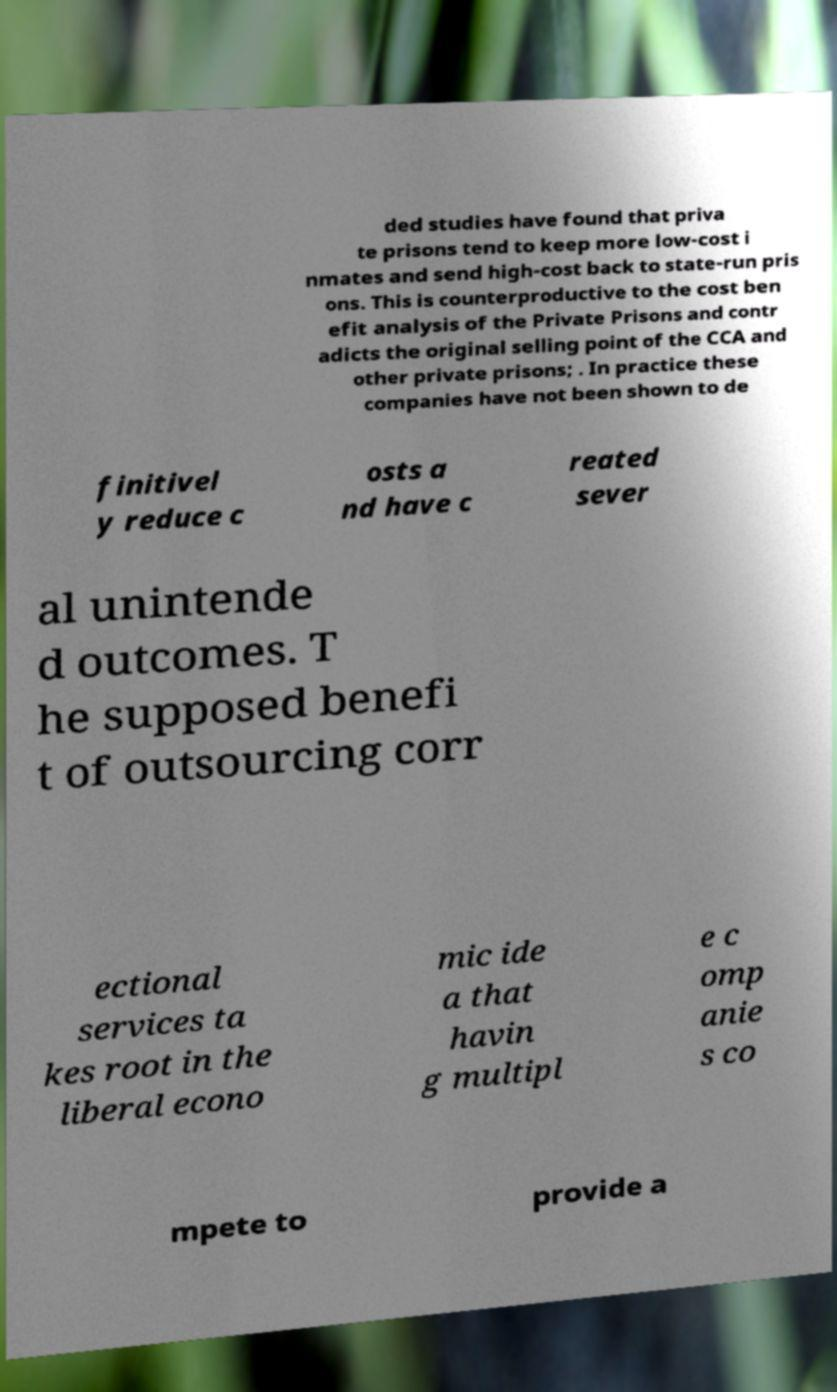Please read and relay the text visible in this image. What does it say? ded studies have found that priva te prisons tend to keep more low-cost i nmates and send high-cost back to state-run pris ons. This is counterproductive to the cost ben efit analysis of the Private Prisons and contr adicts the original selling point of the CCA and other private prisons; . In practice these companies have not been shown to de finitivel y reduce c osts a nd have c reated sever al unintende d outcomes. T he supposed benefi t of outsourcing corr ectional services ta kes root in the liberal econo mic ide a that havin g multipl e c omp anie s co mpete to provide a 